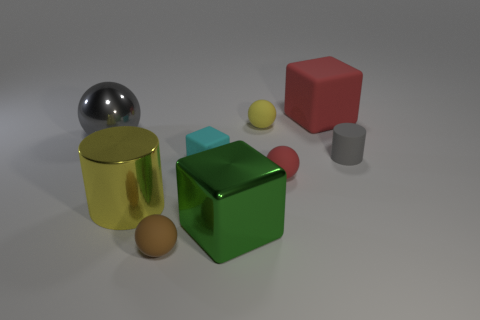Subtract all metal spheres. How many spheres are left? 3 Add 1 large purple cylinders. How many objects exist? 10 Subtract all yellow balls. How many balls are left? 3 Add 1 big yellow cylinders. How many big yellow cylinders are left? 2 Add 6 cyan matte things. How many cyan matte things exist? 7 Subtract 0 blue cylinders. How many objects are left? 9 Subtract all cylinders. How many objects are left? 7 Subtract 3 cubes. How many cubes are left? 0 Subtract all purple spheres. Subtract all purple blocks. How many spheres are left? 4 Subtract all blue cylinders. How many green blocks are left? 1 